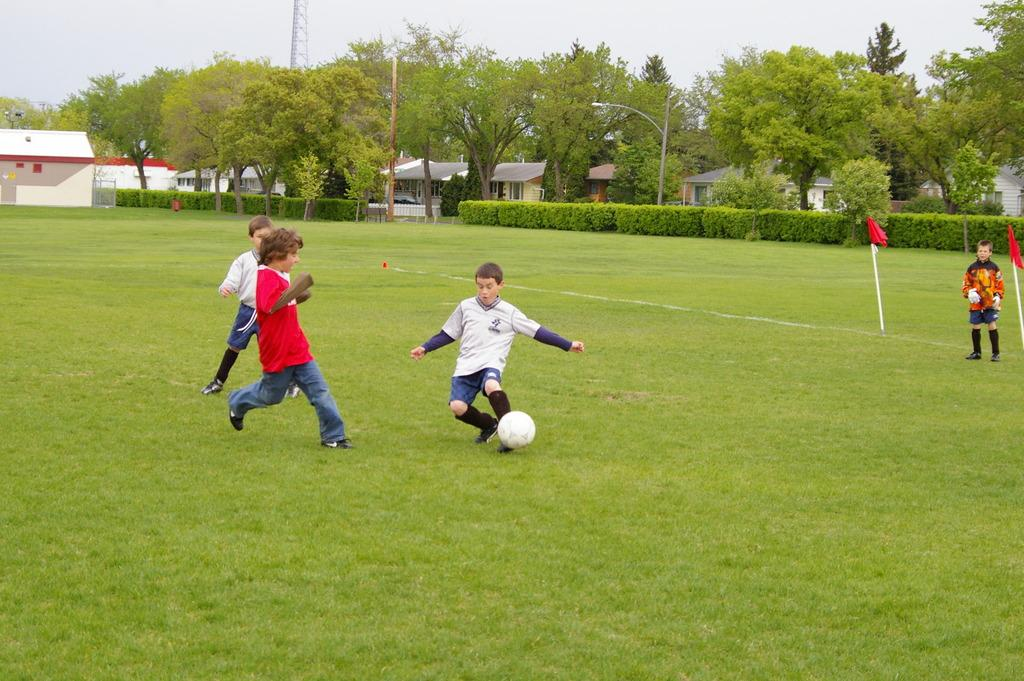What activity are the kids engaged in within the image? The kids are playing football in the image. What type of surface is the football being played on? The football is being played on a grass field. What can be seen in the background of the image? There are trees and homes in the background of the image. What tax rate is applied to the football in the image? There is no mention of taxes or tax rates in the image, as it features kids playing football on a grass field with trees and homes in the background. 